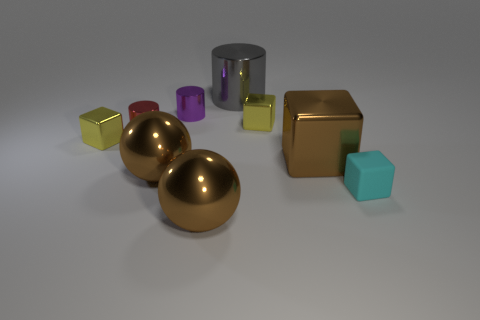There is a small thing that is both in front of the tiny red shiny cylinder and right of the purple thing; what is it made of?
Give a very brief answer. Rubber. There is another cylinder that is the same size as the purple cylinder; what material is it?
Give a very brief answer. Metal. Is there a tiny cyan ball that has the same material as the big cylinder?
Offer a terse response. No. How many brown cubes are there?
Make the answer very short. 1. Does the big gray thing have the same material as the brown ball that is on the left side of the tiny purple cylinder?
Provide a short and direct response. Yes. What number of big shiny things are the same color as the tiny matte thing?
Provide a succinct answer. 0. What size is the purple thing?
Offer a very short reply. Small. Does the tiny cyan matte thing have the same shape as the yellow thing that is on the right side of the small purple metallic cylinder?
Your answer should be very brief. Yes. There is a large block that is made of the same material as the tiny purple thing; what color is it?
Your answer should be very brief. Brown. How big is the gray metallic cylinder behind the small purple metal thing?
Make the answer very short. Large. 